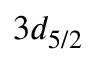<formula> <loc_0><loc_0><loc_500><loc_500>3 d _ { 5 / 2 }</formula> 